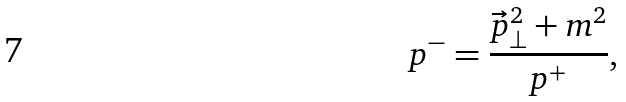Convert formula to latex. <formula><loc_0><loc_0><loc_500><loc_500>p ^ { - } = \frac { { \vec { p } } _ { \perp } ^ { 2 } + m ^ { 2 } } { p ^ { + } } ,</formula> 